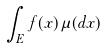<formula> <loc_0><loc_0><loc_500><loc_500>\int _ { E } f ( x ) \mu ( d x )</formula> 